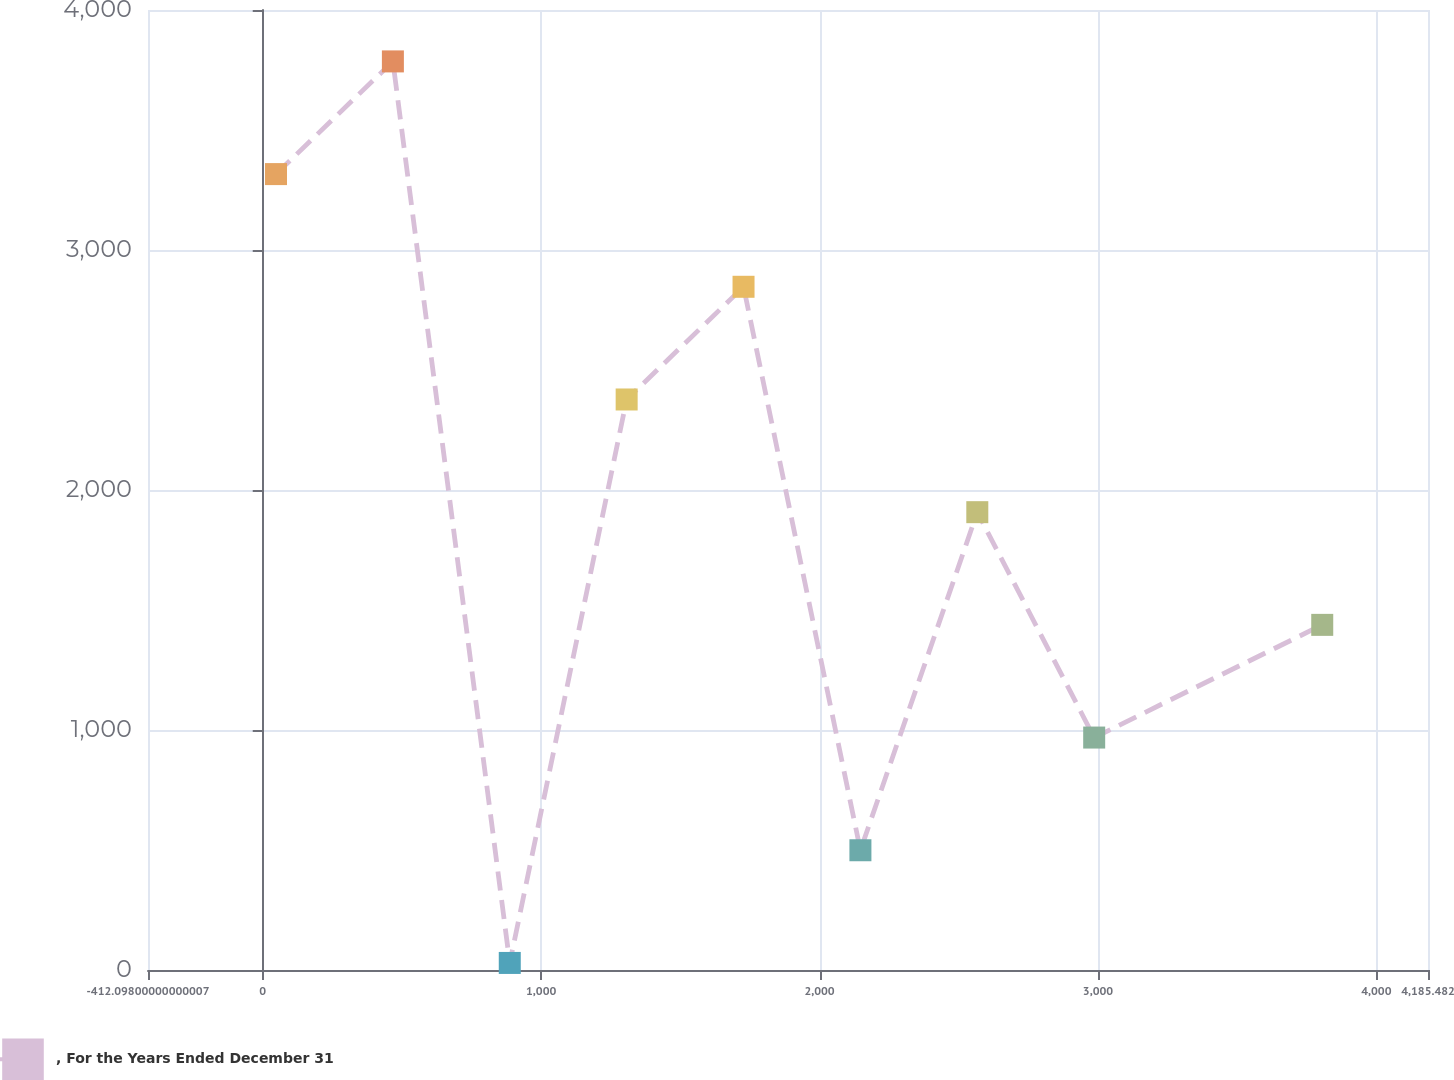<chart> <loc_0><loc_0><loc_500><loc_500><line_chart><ecel><fcel>, For the Years Ended December 31<nl><fcel>47.66<fcel>3316.27<nl><fcel>467.49<fcel>3785.82<nl><fcel>887.32<fcel>29.42<nl><fcel>1307.15<fcel>2377.17<nl><fcel>1726.98<fcel>2846.72<nl><fcel>2146.81<fcel>498.97<nl><fcel>2566.64<fcel>1907.62<nl><fcel>2986.47<fcel>968.52<nl><fcel>3805.58<fcel>1438.07<nl><fcel>4225.41<fcel>5122.04<nl><fcel>4645.24<fcel>4652.49<nl></chart> 